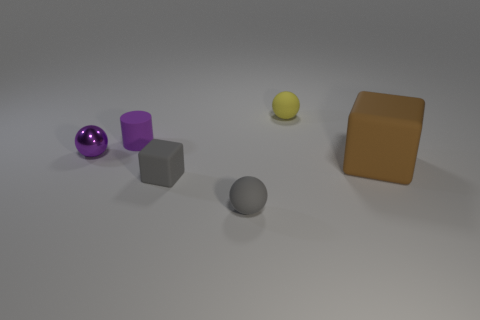The large block is what color?
Give a very brief answer. Brown. What number of objects are either tiny cyan spheres or tiny balls?
Your response must be concise. 3. Does the small cube have the same material as the gray thing in front of the tiny gray cube?
Your response must be concise. Yes. What is the size of the block that is right of the gray matte sphere?
Ensure brevity in your answer.  Large. Are there fewer purple balls than big yellow cylinders?
Offer a very short reply. No. Are there any other tiny things that have the same color as the tiny shiny thing?
Keep it short and to the point. Yes. There is a rubber object that is behind the small matte cube and in front of the purple metal ball; what shape is it?
Make the answer very short. Cube. The gray thing left of the tiny rubber sphere in front of the brown rubber cube is what shape?
Offer a terse response. Cube. Is the shape of the big thing the same as the yellow rubber thing?
Provide a succinct answer. No. What material is the small sphere that is the same color as the tiny cylinder?
Ensure brevity in your answer.  Metal. 